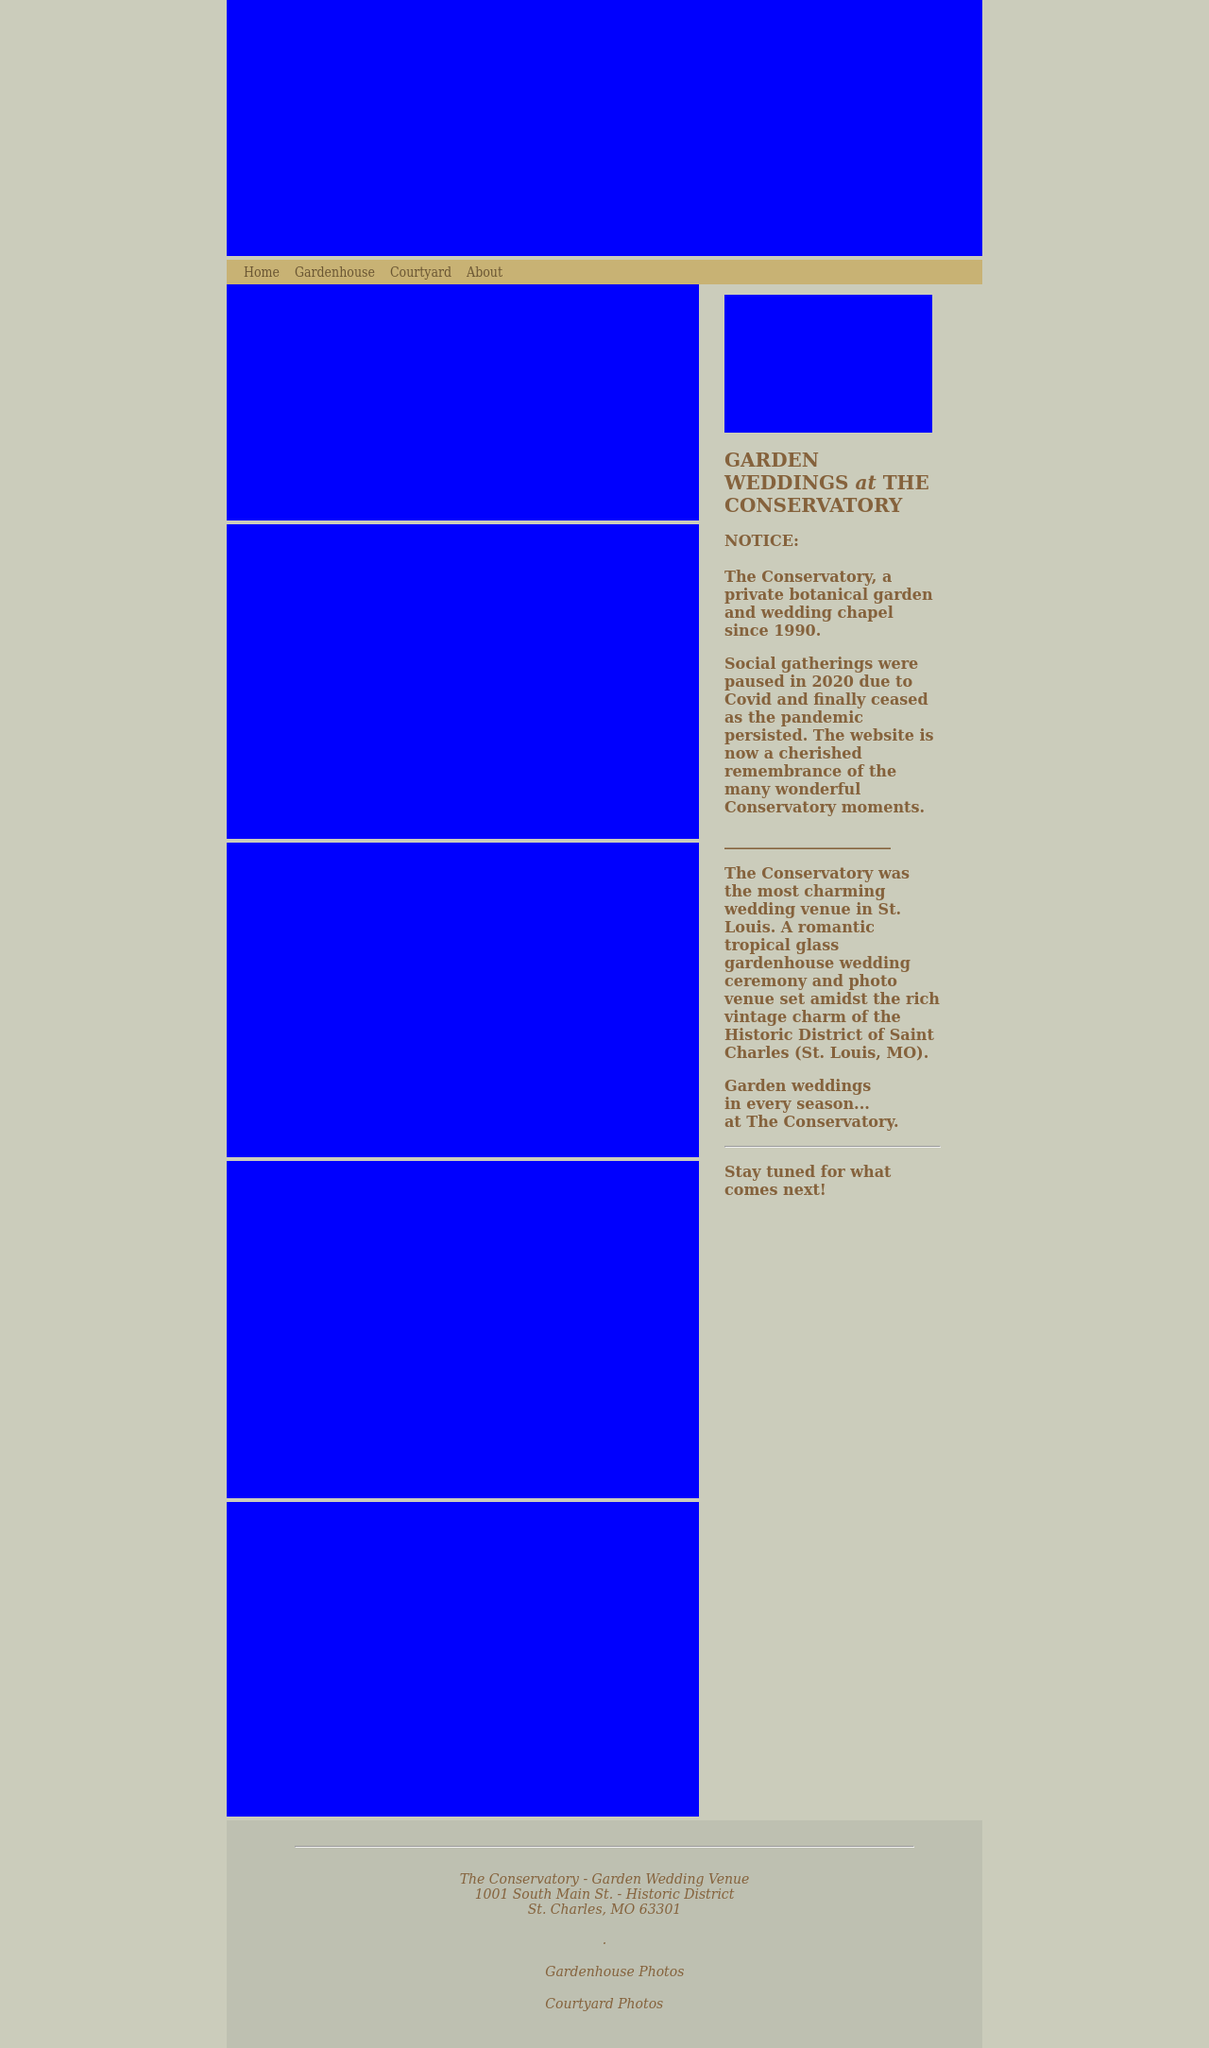Could you detail the process for assembling this website using HTML? Certainly! Assembling a garden wedding themed website using HTML involves several key steps. First, establish the basic structure with HTML, using tags to define the layout, such as <html>, <head>, and <body>. In the <head> section, include links to CSS for styling and possibly JavaScript files for functionality. Then in the <body>, create a navigation bar, possibly using <div> tags for sections like Home, Gardenhouse, and Courtyard. Add content to each section - images can be included using <img> tags, and text with <p> or <h> tags. Finally, ensure the website is responsive to different devices by using media queries in your CSS, making the site user-friendly across all platforms. 